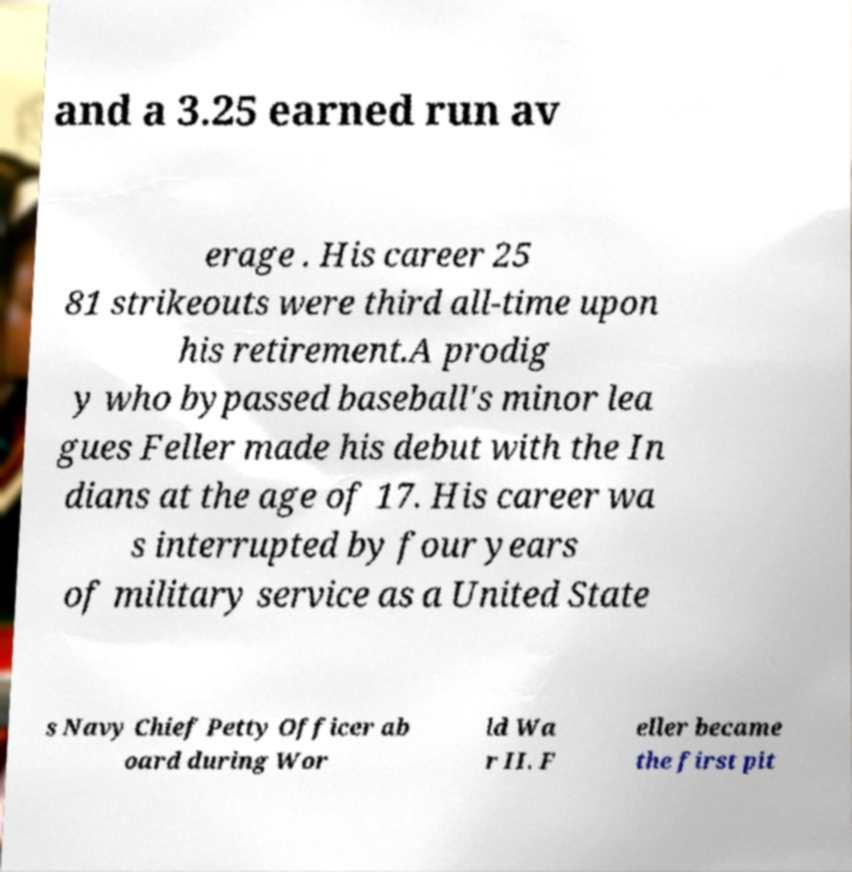What messages or text are displayed in this image? I need them in a readable, typed format. and a 3.25 earned run av erage . His career 25 81 strikeouts were third all-time upon his retirement.A prodig y who bypassed baseball's minor lea gues Feller made his debut with the In dians at the age of 17. His career wa s interrupted by four years of military service as a United State s Navy Chief Petty Officer ab oard during Wor ld Wa r II. F eller became the first pit 